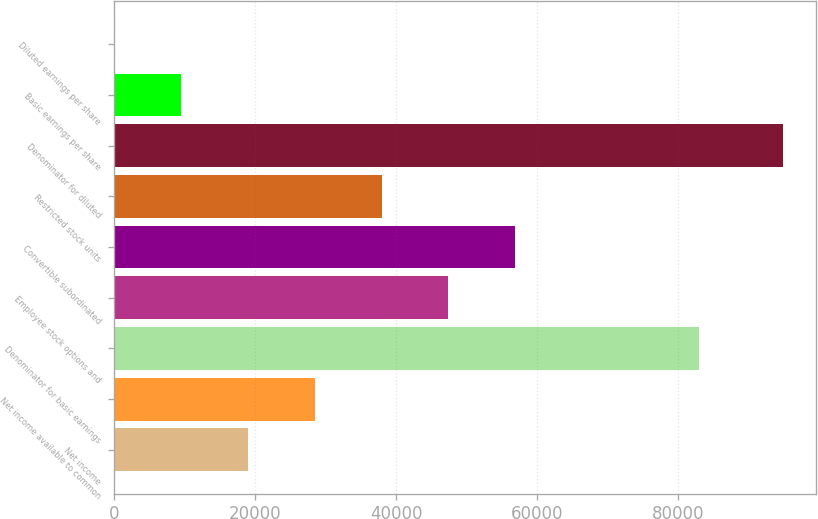<chart> <loc_0><loc_0><loc_500><loc_500><bar_chart><fcel>Net income<fcel>Net income available to common<fcel>Denominator for basic earnings<fcel>Employee stock options and<fcel>Convertible subordinated<fcel>Restricted stock units<fcel>Denominator for diluted<fcel>Basic earnings per share<fcel>Diluted earnings per share<nl><fcel>18970.2<fcel>28455<fcel>82960<fcel>47424.4<fcel>56909.1<fcel>37939.7<fcel>94848<fcel>9485.51<fcel>0.79<nl></chart> 